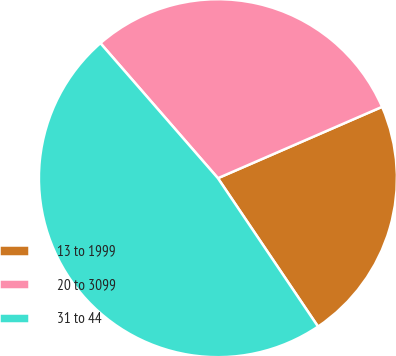Convert chart to OTSL. <chart><loc_0><loc_0><loc_500><loc_500><pie_chart><fcel>13 to 1999<fcel>20 to 3099<fcel>31 to 44<nl><fcel>22.08%<fcel>29.87%<fcel>48.05%<nl></chart> 